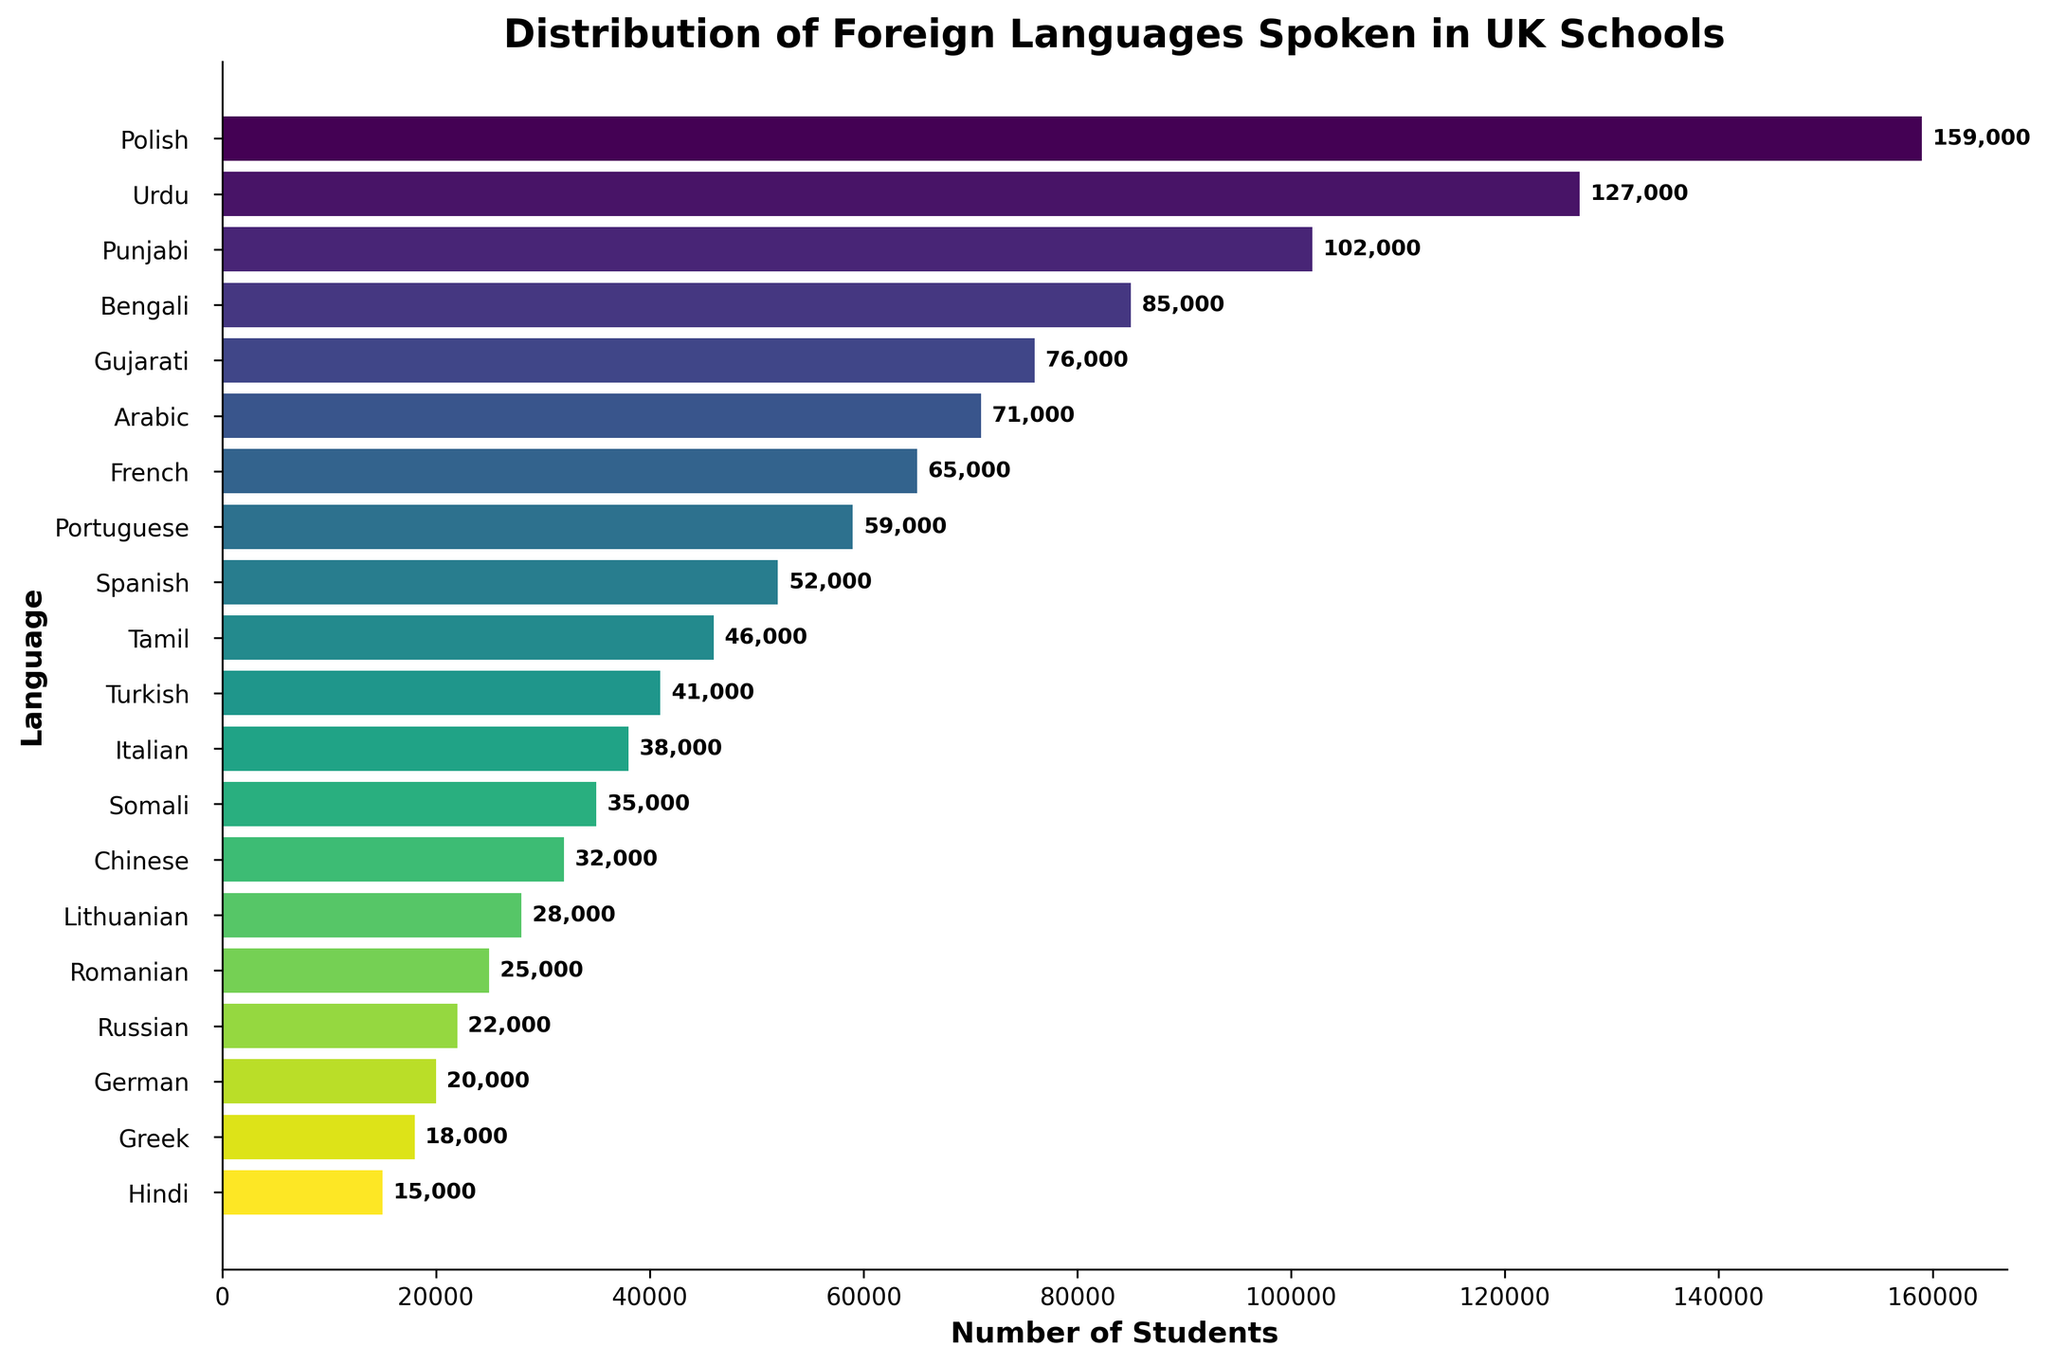Which foreign language has the most number of students speaking it? The bar with the longest length represents the language spoken by the most students. This is the bar for Polish.
Answer: Polish What is the difference in the number of students between the language spoken by the most students and the language spoken by the fewest students? The number of students for Polish is 159,000, and the number for Hindi is 15,000. Subtracting the two gives 159,000 - 15,000 = 144,000.
Answer: 144,000 How many students speak languages with more than 50,000 speakers? Add the number of students for Polish, Urdu, Punjabi, Bengali, Gujarati, Arabic, French, and Portuguese. 159,000 + 127,000 + 102,000 + 85,000 + 76,000 + 71,000 + 65,000 + 59,000 = 744,000.
Answer: 744,000 Which language is spoken by more students: Italian or Turkish? Compare the bars for Italian and Turkish. The bar for Turkish (41,000) is longer than the bar for Italian (38,000).
Answer: Turkish What is the average number of students speaking the top three most spoken foreign languages? The number of students for the top three languages (Polish, Urdu, and Punjabi) are 159,000, 127,000, and 102,000 respectively. The sum is 159,000 + 127,000 + 102,000 = 388,000. Divide by 3: 388,000 / 3 ≈ 129,333.
Answer: 129,333 Which languages have fewer than 40,000 students speaking them? Identify the bars that have lengths corresponding to fewer than 40,000 students. These are Chinese, Lithuanian, Romanian, Russian, German, Greek, and Hindi.
Answer: Chinese, Lithuanian, Romanian, Russian, German, Greek, Hindi What is the combined number of students speaking Bengali and Arabic? Add the number of students for Bengali (85,000) and Arabic (71,000). 85,000 + 71,000 = 156,000.
Answer: 156,000 How many more students speak Spanish compared to Tamil? Identify the number of students for Spanish (52,000) and Tamil (46,000). Subtract the two: 52,000 - 46,000 = 6,000.
Answer: 6,000 